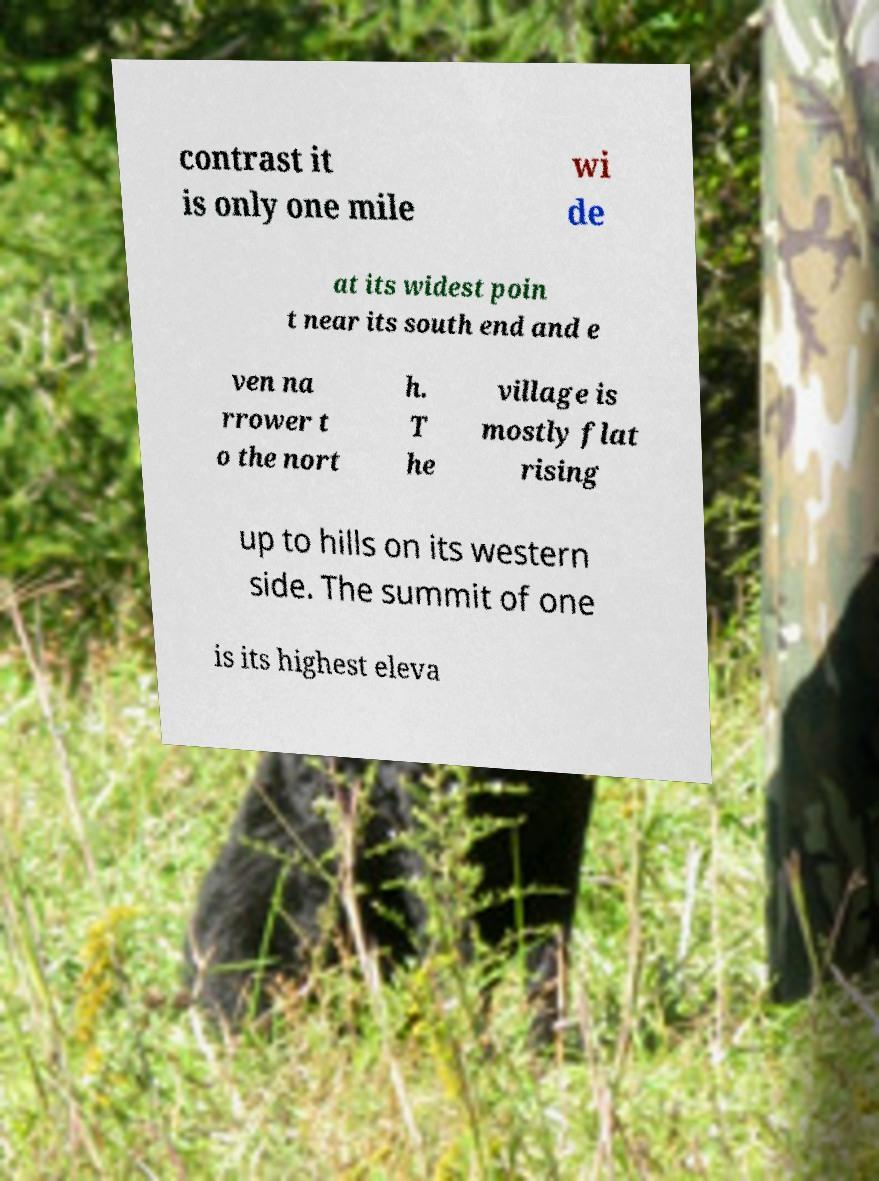For documentation purposes, I need the text within this image transcribed. Could you provide that? contrast it is only one mile wi de at its widest poin t near its south end and e ven na rrower t o the nort h. T he village is mostly flat rising up to hills on its western side. The summit of one is its highest eleva 